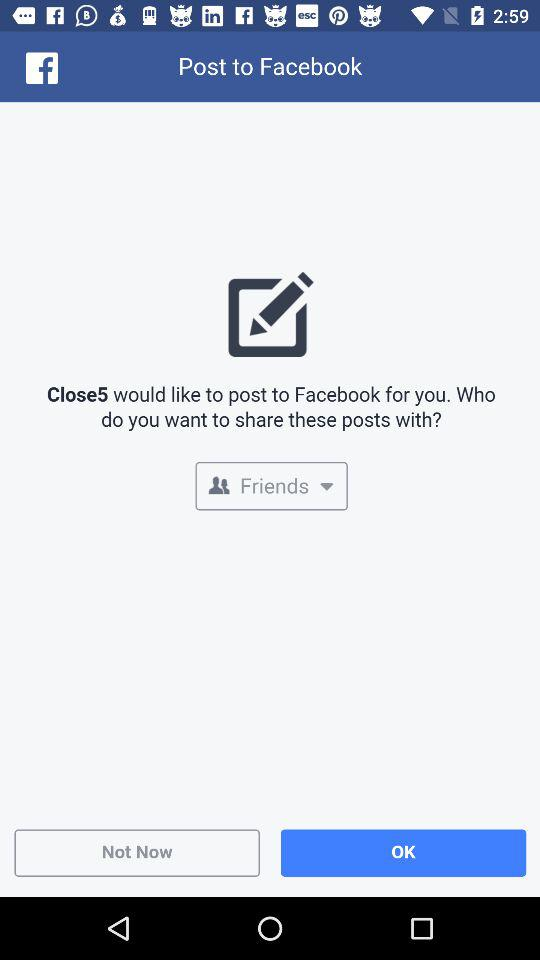Through what application are we logged in? We are logged in through Facebook. 